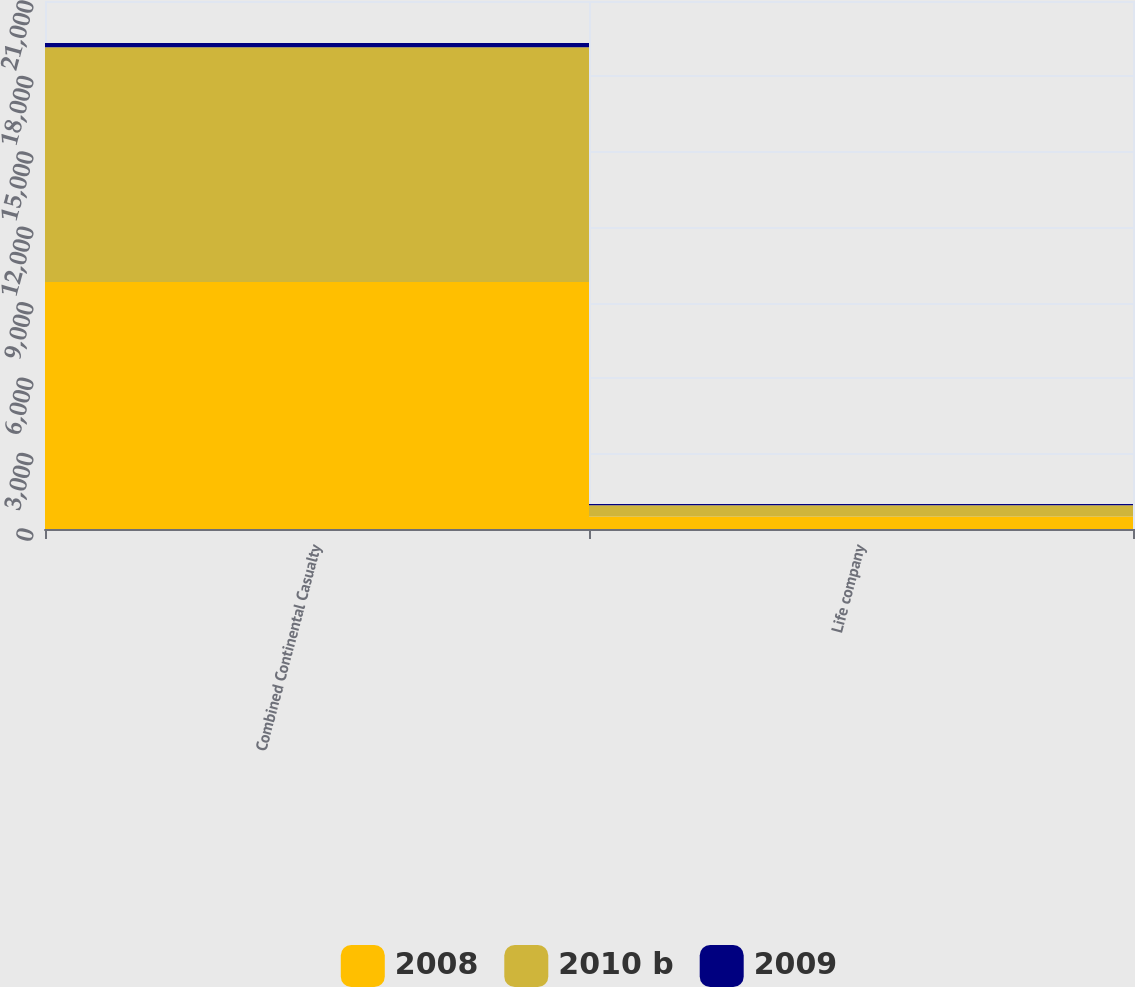Convert chart. <chart><loc_0><loc_0><loc_500><loc_500><stacked_bar_chart><ecel><fcel>Combined Continental Casualty<fcel>Life company<nl><fcel>2008<fcel>9821<fcel>498<nl><fcel>2010 b<fcel>9338<fcel>448<nl><fcel>2009<fcel>172<fcel>51<nl></chart> 